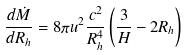<formula> <loc_0><loc_0><loc_500><loc_500>\frac { d \dot { M } } { d R _ { h } } = 8 \pi u ^ { 2 } \frac { c ^ { 2 } } { R _ { h } ^ { 4 } } \left ( \frac { 3 } { H } - 2 R _ { h } \right )</formula> 